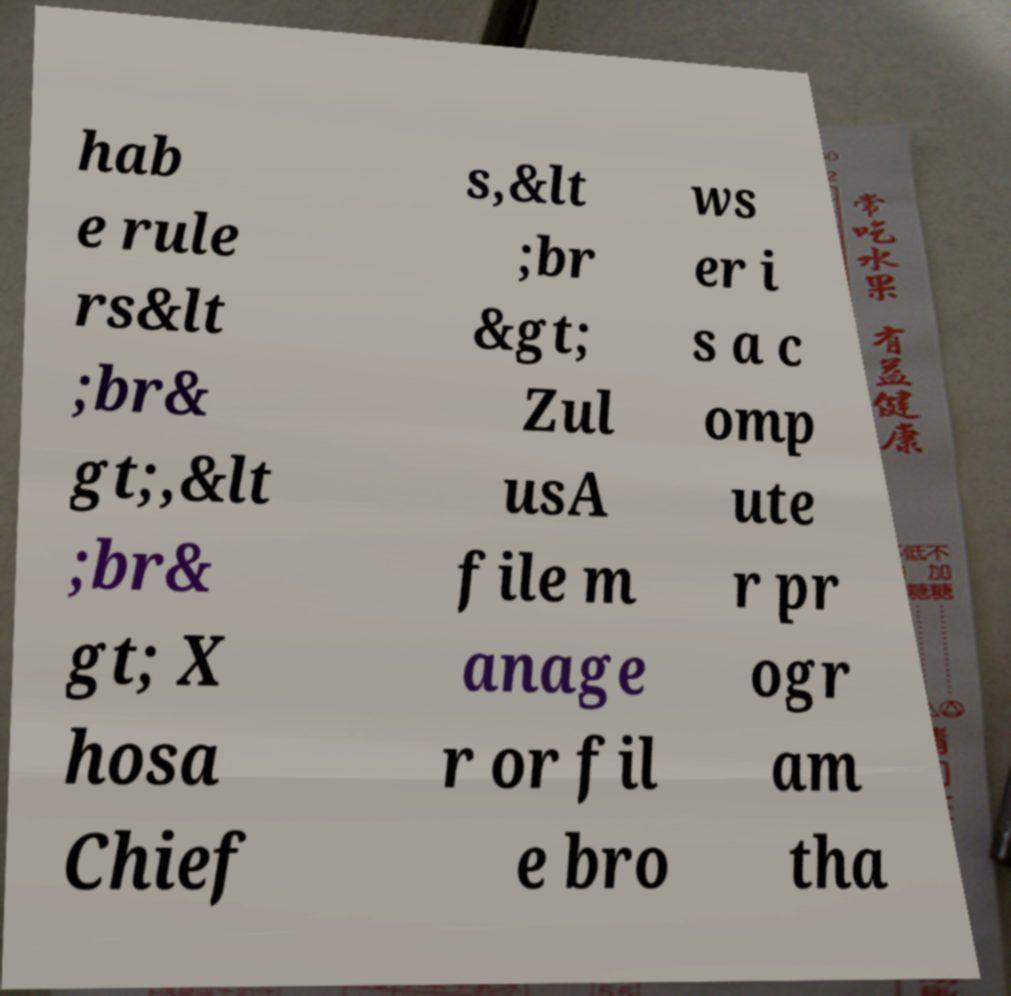Could you extract and type out the text from this image? hab e rule rs&lt ;br& gt;,&lt ;br& gt; X hosa Chief s,&lt ;br &gt; Zul usA file m anage r or fil e bro ws er i s a c omp ute r pr ogr am tha 